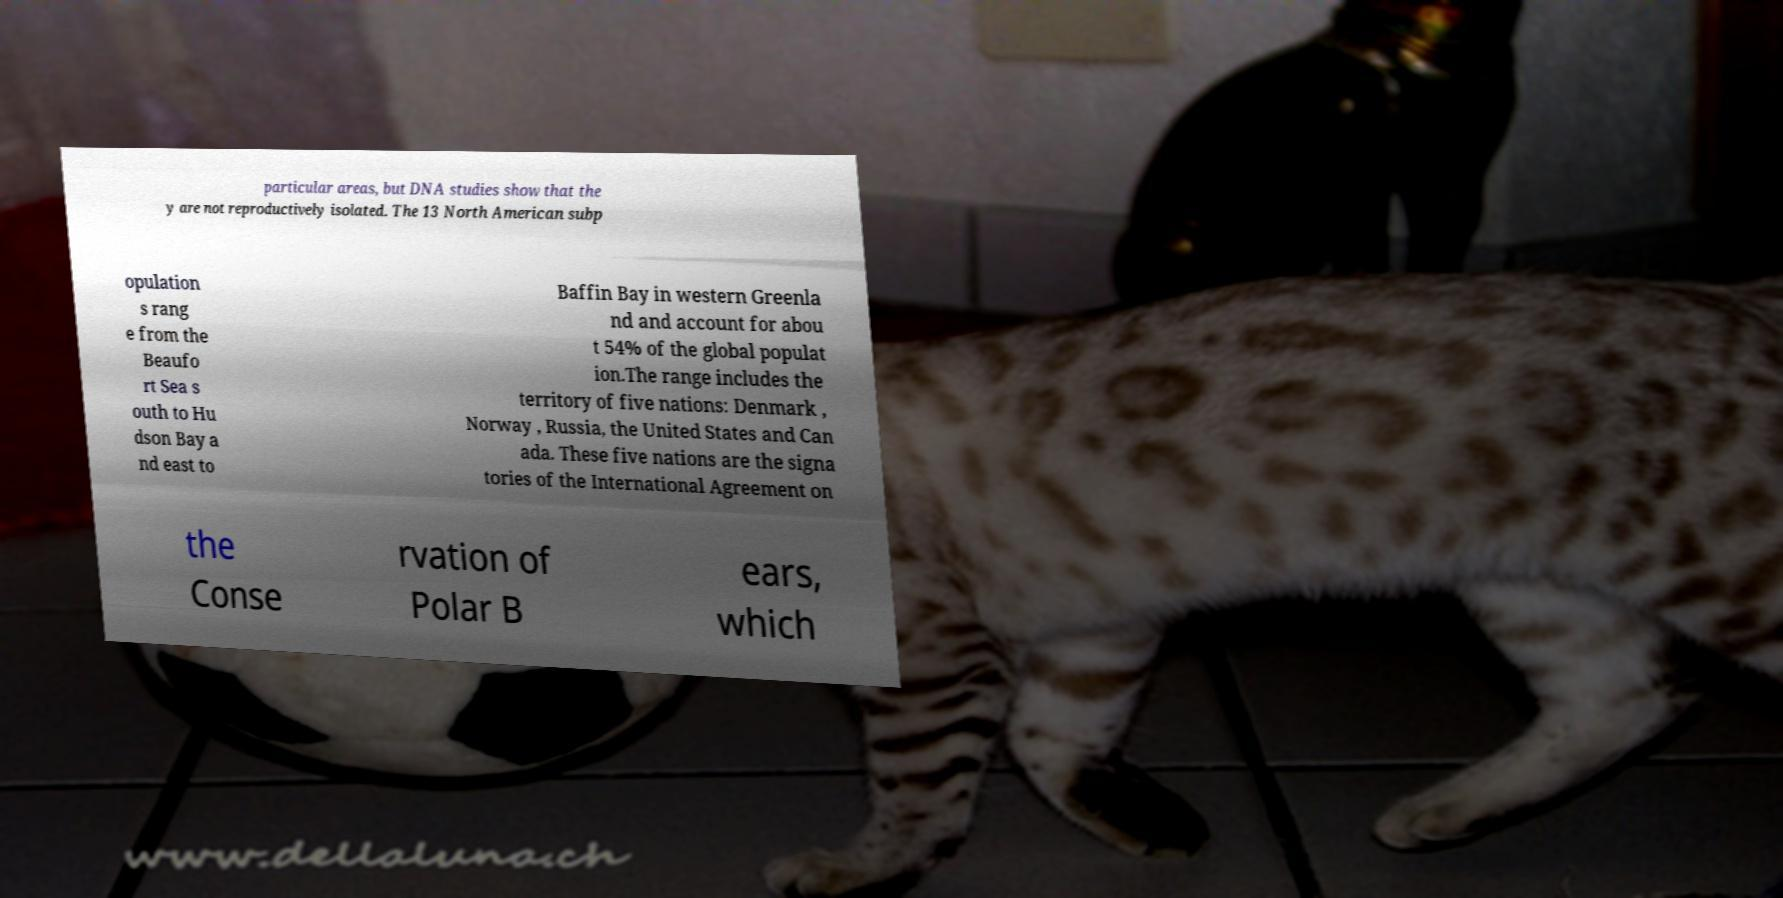Can you accurately transcribe the text from the provided image for me? particular areas, but DNA studies show that the y are not reproductively isolated. The 13 North American subp opulation s rang e from the Beaufo rt Sea s outh to Hu dson Bay a nd east to Baffin Bay in western Greenla nd and account for abou t 54% of the global populat ion.The range includes the territory of five nations: Denmark , Norway , Russia, the United States and Can ada. These five nations are the signa tories of the International Agreement on the Conse rvation of Polar B ears, which 